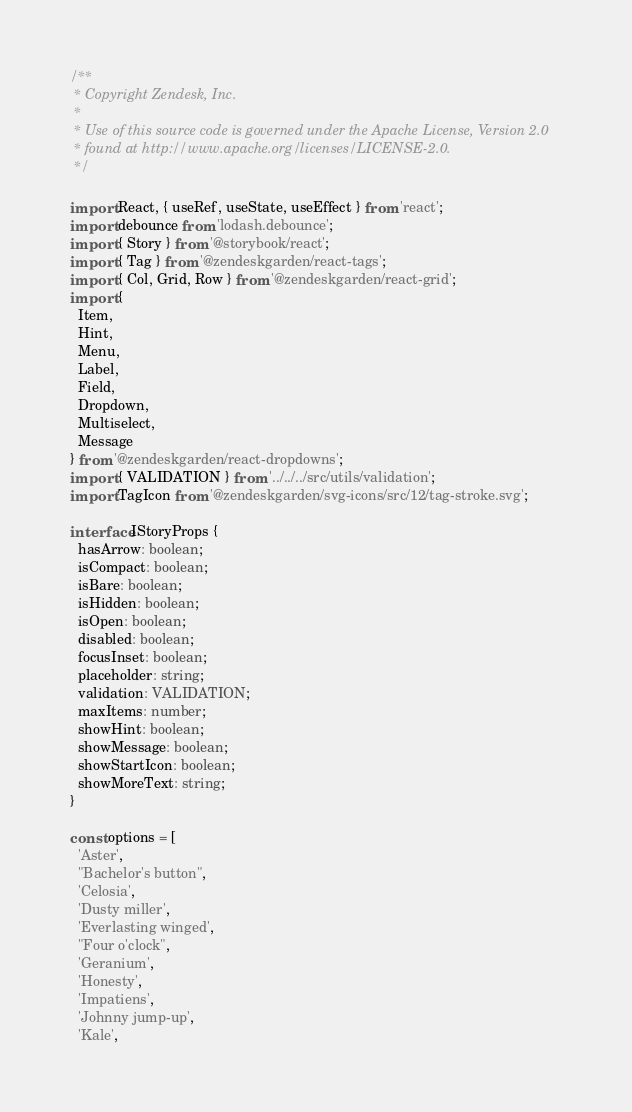Convert code to text. <code><loc_0><loc_0><loc_500><loc_500><_TypeScript_>/**
 * Copyright Zendesk, Inc.
 *
 * Use of this source code is governed under the Apache License, Version 2.0
 * found at http://www.apache.org/licenses/LICENSE-2.0.
 */

import React, { useRef, useState, useEffect } from 'react';
import debounce from 'lodash.debounce';
import { Story } from '@storybook/react';
import { Tag } from '@zendeskgarden/react-tags';
import { Col, Grid, Row } from '@zendeskgarden/react-grid';
import {
  Item,
  Hint,
  Menu,
  Label,
  Field,
  Dropdown,
  Multiselect,
  Message
} from '@zendeskgarden/react-dropdowns';
import { VALIDATION } from '../../../src/utils/validation';
import TagIcon from '@zendeskgarden/svg-icons/src/12/tag-stroke.svg';

interface IStoryProps {
  hasArrow: boolean;
  isCompact: boolean;
  isBare: boolean;
  isHidden: boolean;
  isOpen: boolean;
  disabled: boolean;
  focusInset: boolean;
  placeholder: string;
  validation: VALIDATION;
  maxItems: number;
  showHint: boolean;
  showMessage: boolean;
  showStartIcon: boolean;
  showMoreText: string;
}

const options = [
  'Aster',
  "Bachelor's button",
  'Celosia',
  'Dusty miller',
  'Everlasting winged',
  "Four o'clock",
  'Geranium',
  'Honesty',
  'Impatiens',
  'Johnny jump-up',
  'Kale',</code> 